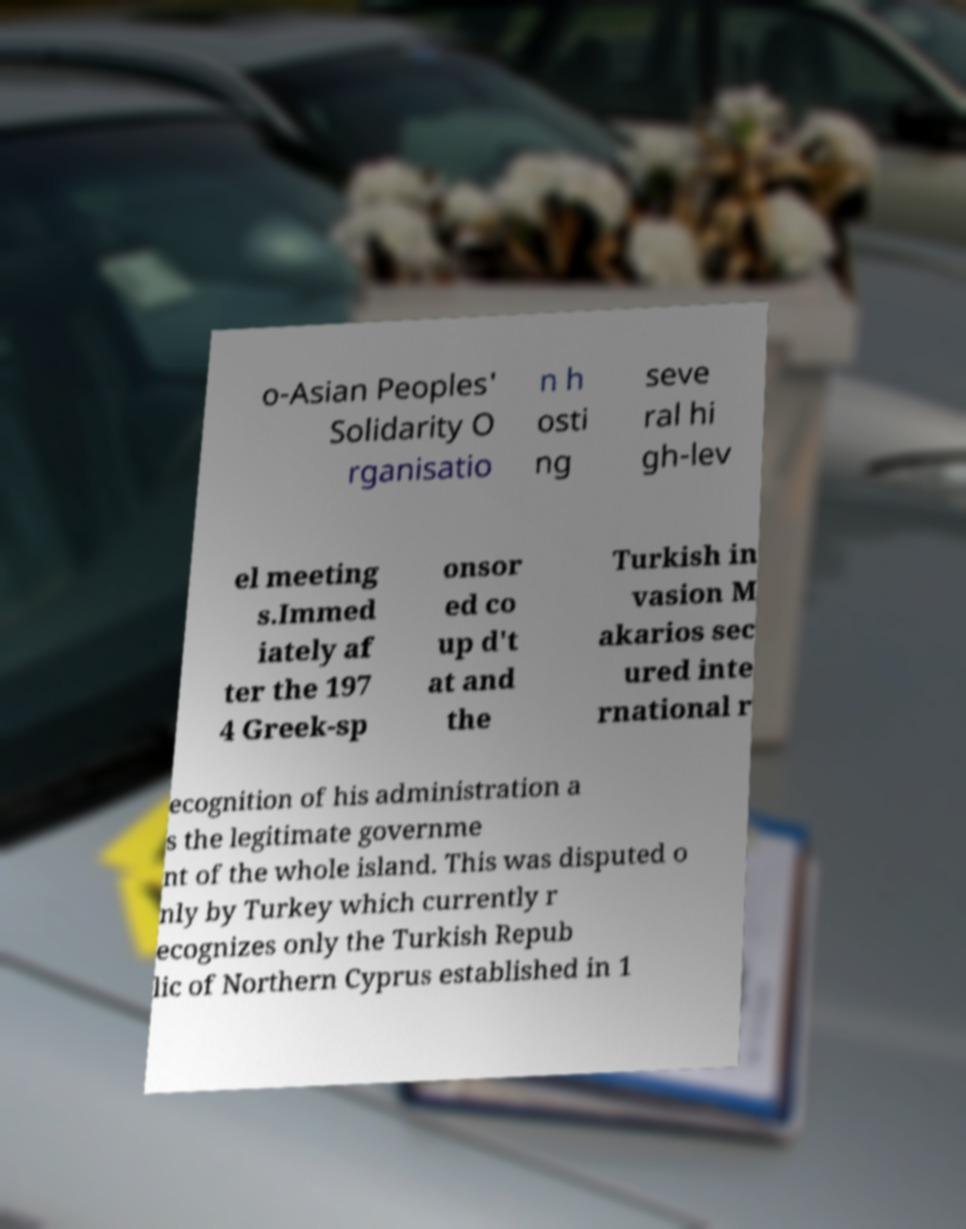Could you assist in decoding the text presented in this image and type it out clearly? o-Asian Peoples' Solidarity O rganisatio n h osti ng seve ral hi gh-lev el meeting s.Immed iately af ter the 197 4 Greek-sp onsor ed co up d't at and the Turkish in vasion M akarios sec ured inte rnational r ecognition of his administration a s the legitimate governme nt of the whole island. This was disputed o nly by Turkey which currently r ecognizes only the Turkish Repub lic of Northern Cyprus established in 1 